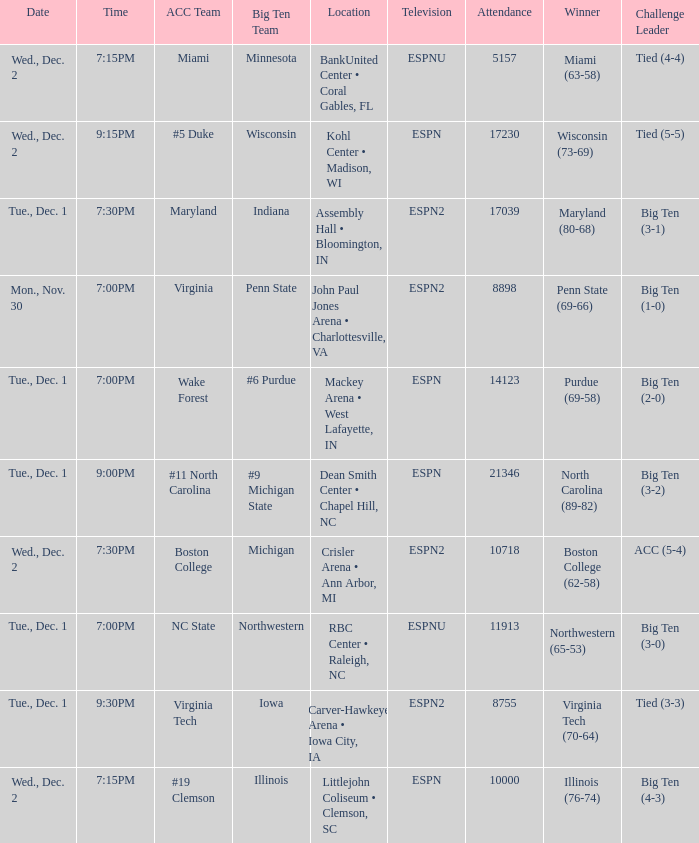Name the location for illinois Littlejohn Coliseum • Clemson, SC. 